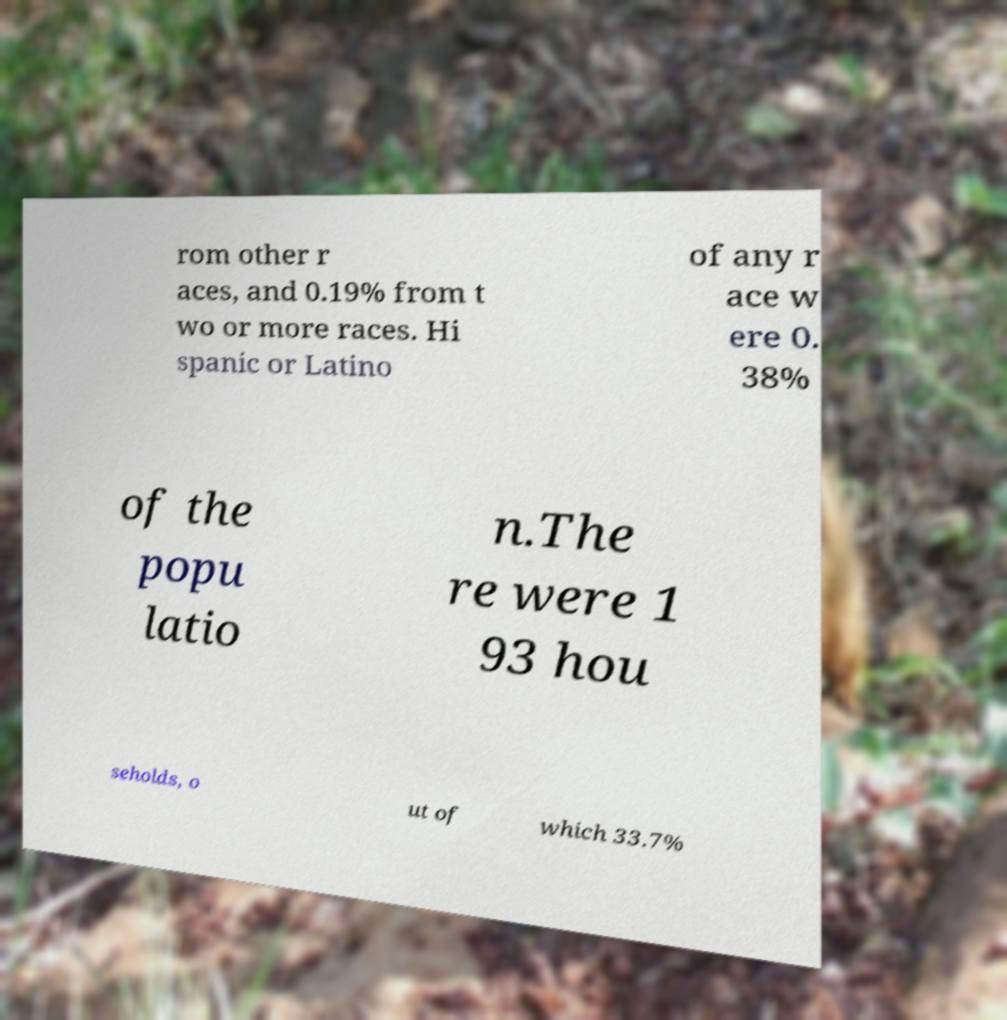Can you accurately transcribe the text from the provided image for me? rom other r aces, and 0.19% from t wo or more races. Hi spanic or Latino of any r ace w ere 0. 38% of the popu latio n.The re were 1 93 hou seholds, o ut of which 33.7% 